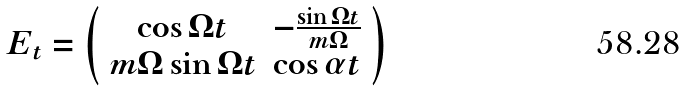Convert formula to latex. <formula><loc_0><loc_0><loc_500><loc_500>E _ { t } = \left ( \begin{array} { c c } \cos \Omega t & - \frac { \sin \Omega t } { m \Omega } \\ m \Omega \sin \Omega t & \cos \alpha t \end{array} \right )</formula> 